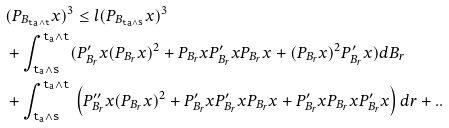<formula> <loc_0><loc_0><loc_500><loc_500>& ( P _ { B _ { \tt t _ { a } \wedge t } } x ) ^ { 3 } \leq l ( P _ { B _ { \tt t _ { a } \wedge s } } x ) ^ { 3 } \\ & + \int _ { \tt t _ { a } \wedge s } ^ { \tt t _ { a } \wedge t } ( P ^ { \prime } _ { B _ { r } } x ( P _ { B _ { r } } x ) ^ { 2 } + P _ { B _ { r } } x P ^ { \prime } _ { B _ { r } } x P _ { B _ { r } } x + ( P _ { B _ { r } } x ) ^ { 2 } P ^ { \prime } _ { B _ { r } } x ) d B _ { r } \\ & + \int _ { \tt t _ { a } \wedge s } ^ { \tt t _ { a } \wedge t } \, \left ( P ^ { \prime \prime } _ { B _ { r } } x ( P _ { B _ { r } } x ) ^ { 2 } + P ^ { \prime } _ { B _ { r } } x P ^ { \prime } _ { B _ { r } } x P _ { B _ { r } } x + P ^ { \prime } _ { B _ { r } } x P _ { B _ { r } } x P ^ { \prime } _ { B _ { r } } x \right ) d r + . .</formula> 